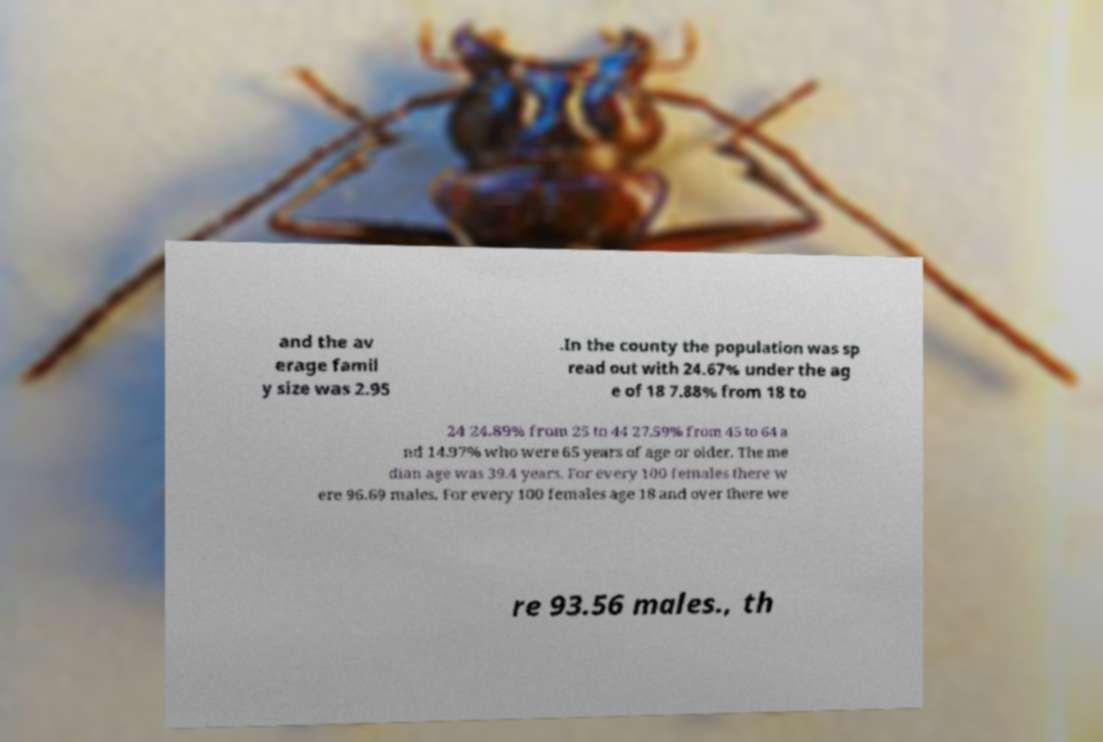What messages or text are displayed in this image? I need them in a readable, typed format. and the av erage famil y size was 2.95 .In the county the population was sp read out with 24.67% under the ag e of 18 7.88% from 18 to 24 24.89% from 25 to 44 27.59% from 45 to 64 a nd 14.97% who were 65 years of age or older. The me dian age was 39.4 years. For every 100 females there w ere 96.69 males. For every 100 females age 18 and over there we re 93.56 males., th 